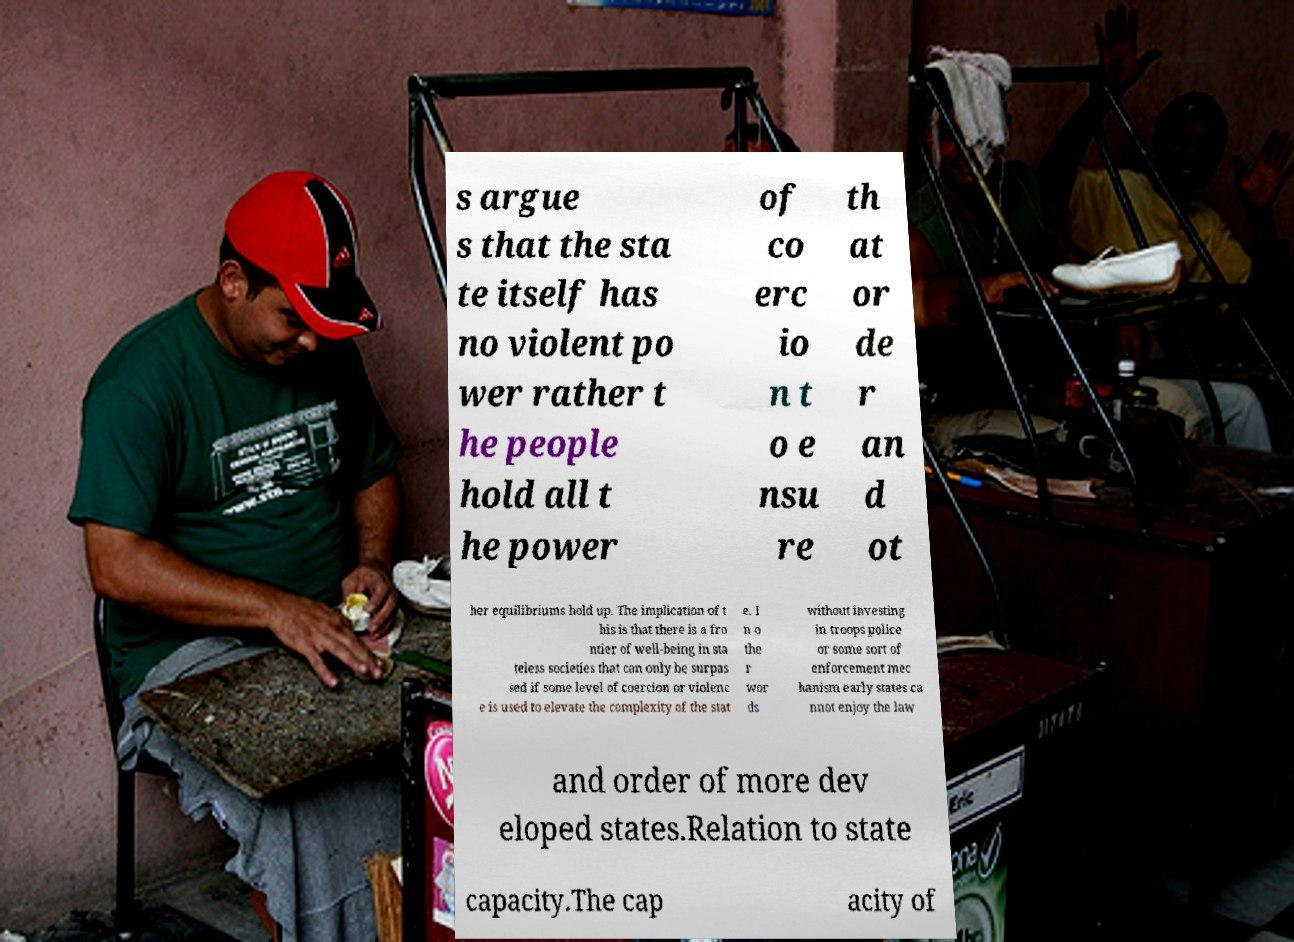For documentation purposes, I need the text within this image transcribed. Could you provide that? s argue s that the sta te itself has no violent po wer rather t he people hold all t he power of co erc io n t o e nsu re th at or de r an d ot her equilibriums hold up. The implication of t his is that there is a fro ntier of well-being in sta teless societies that can only be surpas sed if some level of coercion or violenc e is used to elevate the complexity of the stat e. I n o the r wor ds without investing in troops police or some sort of enforcement mec hanism early states ca nnot enjoy the law and order of more dev eloped states.Relation to state capacity.The cap acity of 